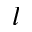Convert formula to latex. <formula><loc_0><loc_0><loc_500><loc_500>l</formula> 